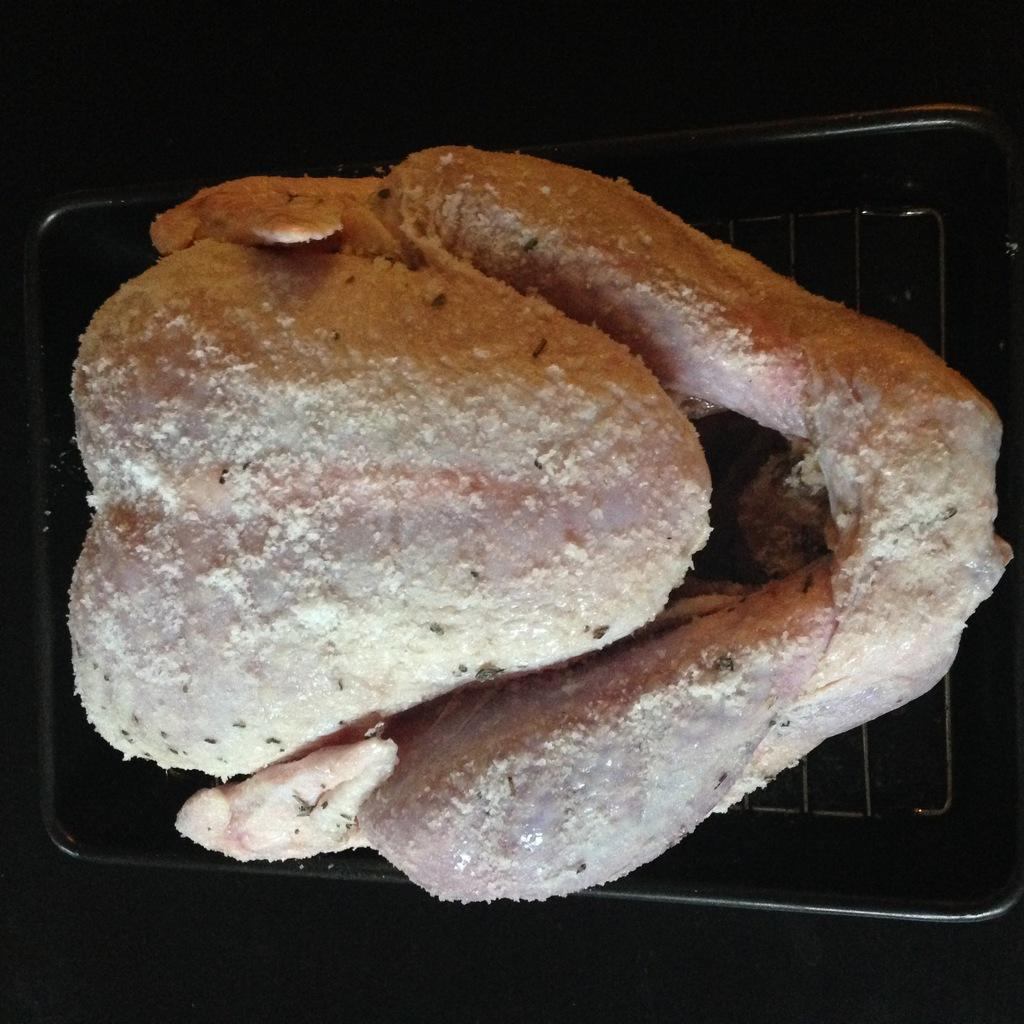What object is present in the image that can hold food or other items? There is a tray in the image. What type of food is on the tray? There is chicken on the tray. What can be observed about the lighting or color of the background in the image? The background of the image is dark. What group of people is playing baseball in the image? There is no group of people playing baseball in the image; it only features a tray with chicken and a dark background. What type of feast is being prepared in the image? There is no indication of a feast being prepared in the image; it only shows a tray with chicken and a dark background. 